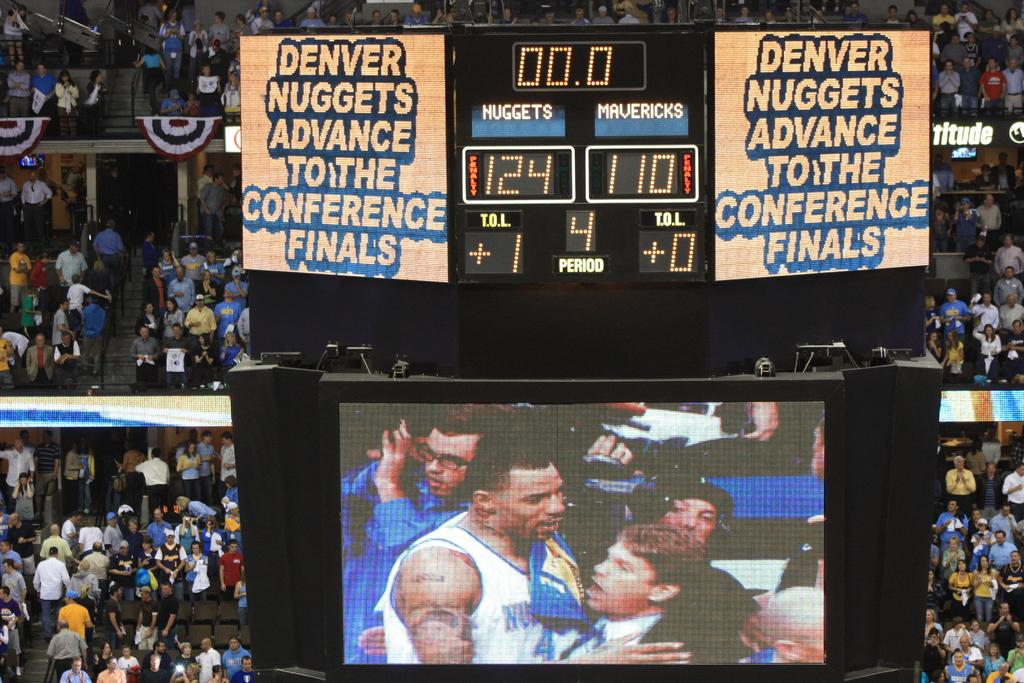Provide a one-sentence caption for the provided image. The Denver Nuggets have just advanced to the conference finals, according to the Jumbotron. 